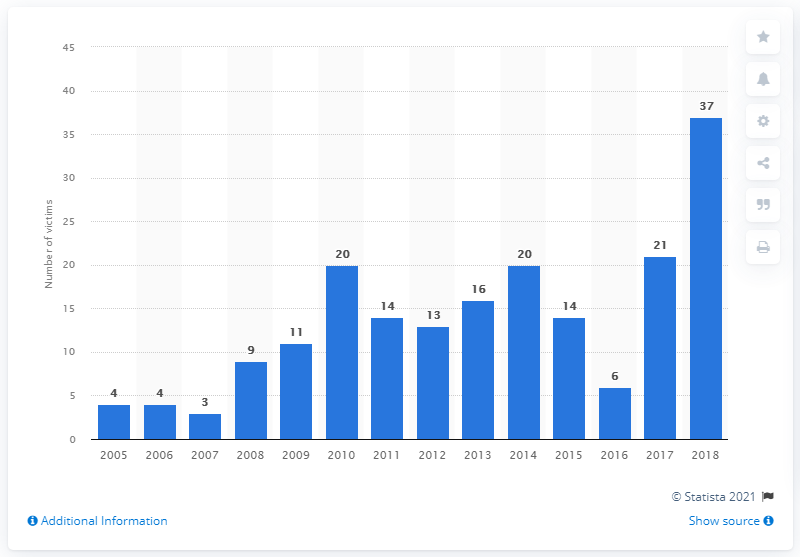How many mayors, mayoral candidates, and former mayors were murdered in Mexico in 2018? In 2018, there were 37 mayors, mayoral candidates, and former mayors who were tragically murdered in Mexico, reflecting a significant spike in violence against political figures compared to prior years, as visually indicated in the provided bar graph. 